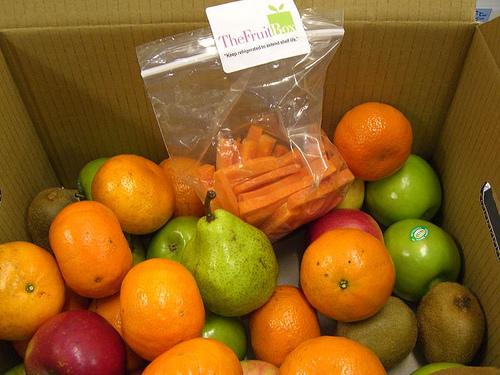How many kiwis in the box?
Concise answer only. 3. How long can you keep fruit in a box?
Answer briefly. Week. What kind of box is the fruit in?
Be succinct. Cardboard. 